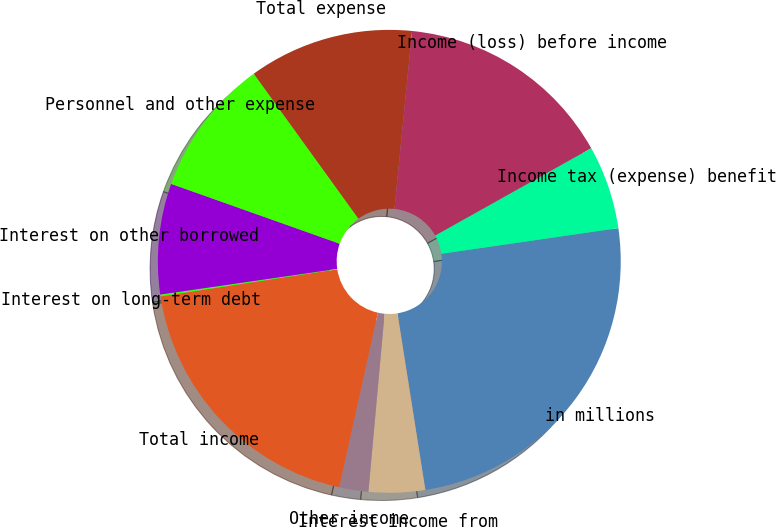Convert chart. <chart><loc_0><loc_0><loc_500><loc_500><pie_chart><fcel>in millions<fcel>Interest income from<fcel>Other income<fcel>Total income<fcel>Interest on long-term debt<fcel>Interest on other borrowed<fcel>Personnel and other expense<fcel>Total expense<fcel>Income (loss) before income<fcel>Income tax (expense) benefit<nl><fcel>24.8%<fcel>3.93%<fcel>2.03%<fcel>19.11%<fcel>0.13%<fcel>7.72%<fcel>9.62%<fcel>11.52%<fcel>15.31%<fcel>5.83%<nl></chart> 